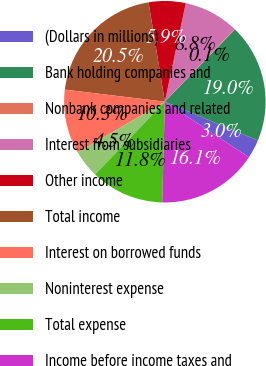<chart> <loc_0><loc_0><loc_500><loc_500><pie_chart><fcel>(Dollars in millions)<fcel>Bank holding companies and<fcel>Nonbank companies and related<fcel>Interest from subsidiaries<fcel>Other income<fcel>Total income<fcel>Interest on borrowed funds<fcel>Noninterest expense<fcel>Total expense<fcel>Income before income taxes and<nl><fcel>3.01%<fcel>19.03%<fcel>0.09%<fcel>8.83%<fcel>5.92%<fcel>20.49%<fcel>10.29%<fcel>4.46%<fcel>11.75%<fcel>16.12%<nl></chart> 